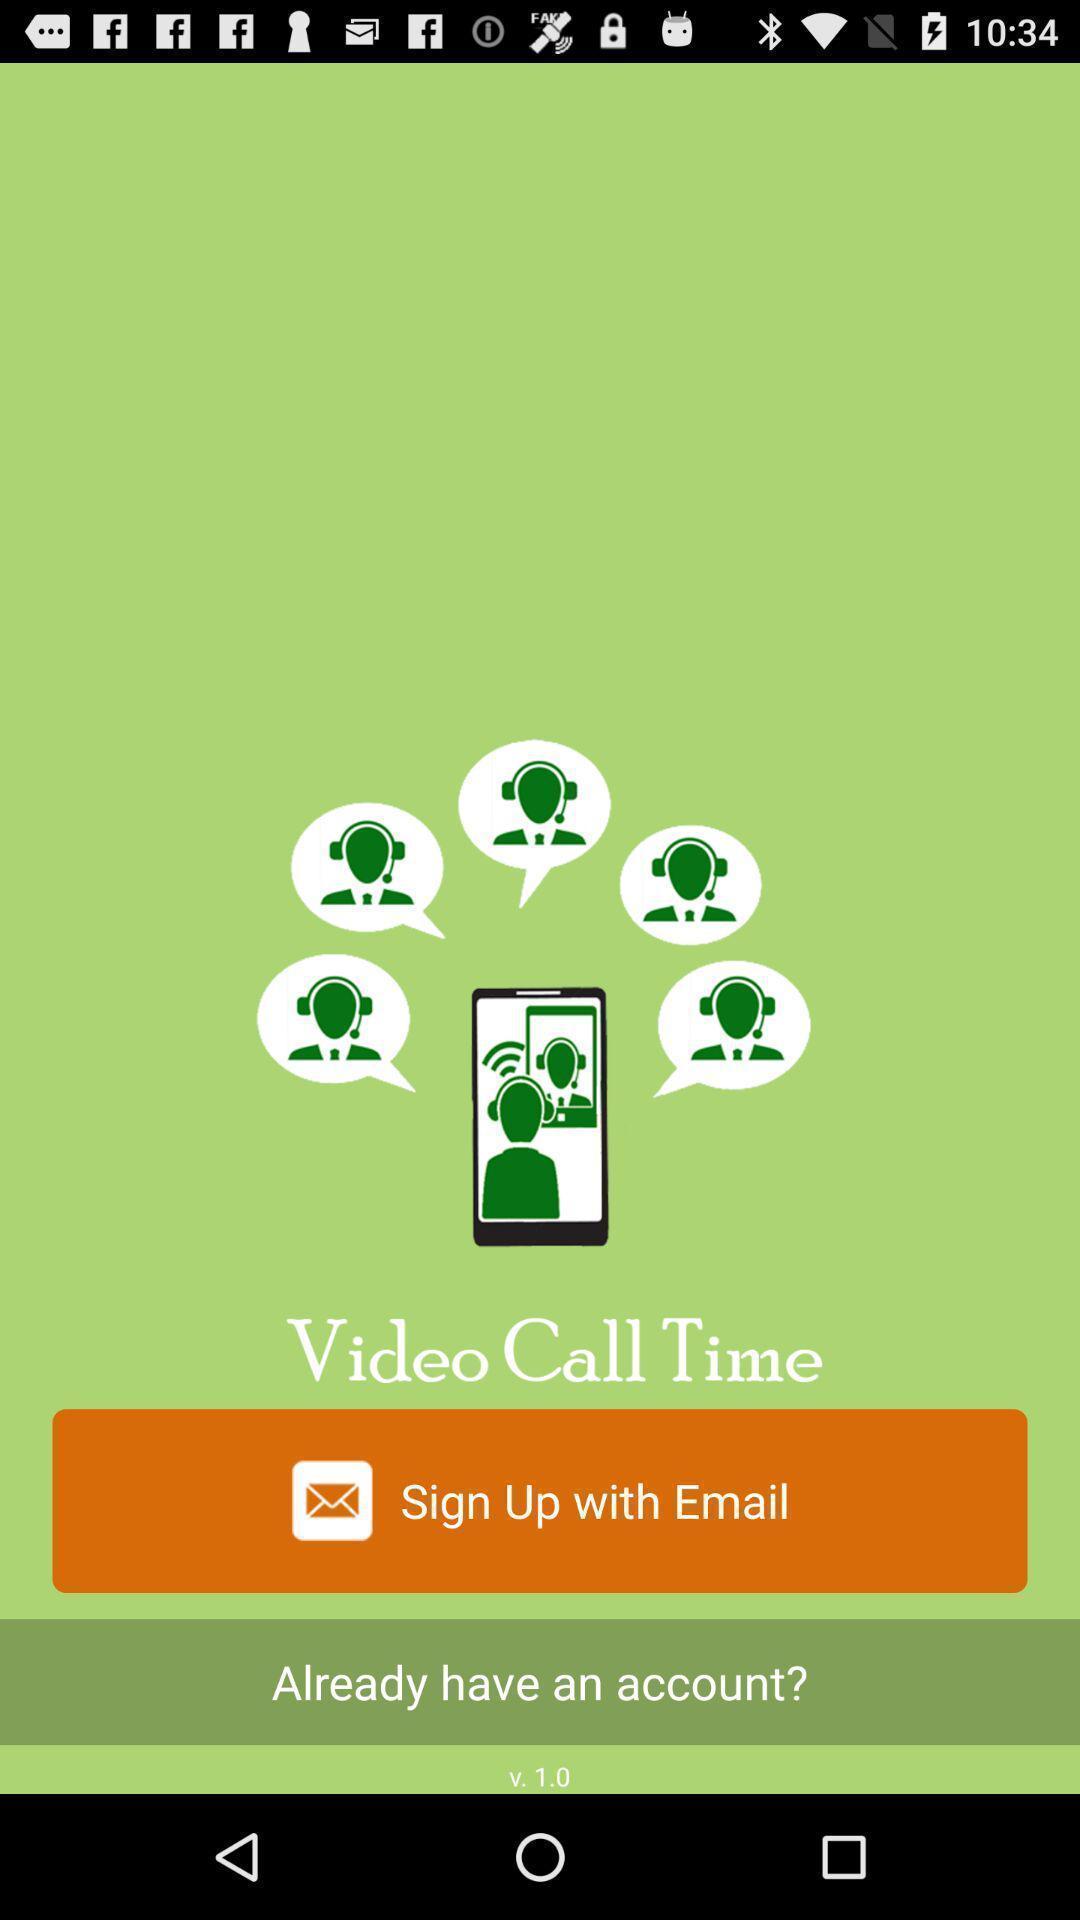Tell me about the visual elements in this screen capture. Sign up page of social app. 